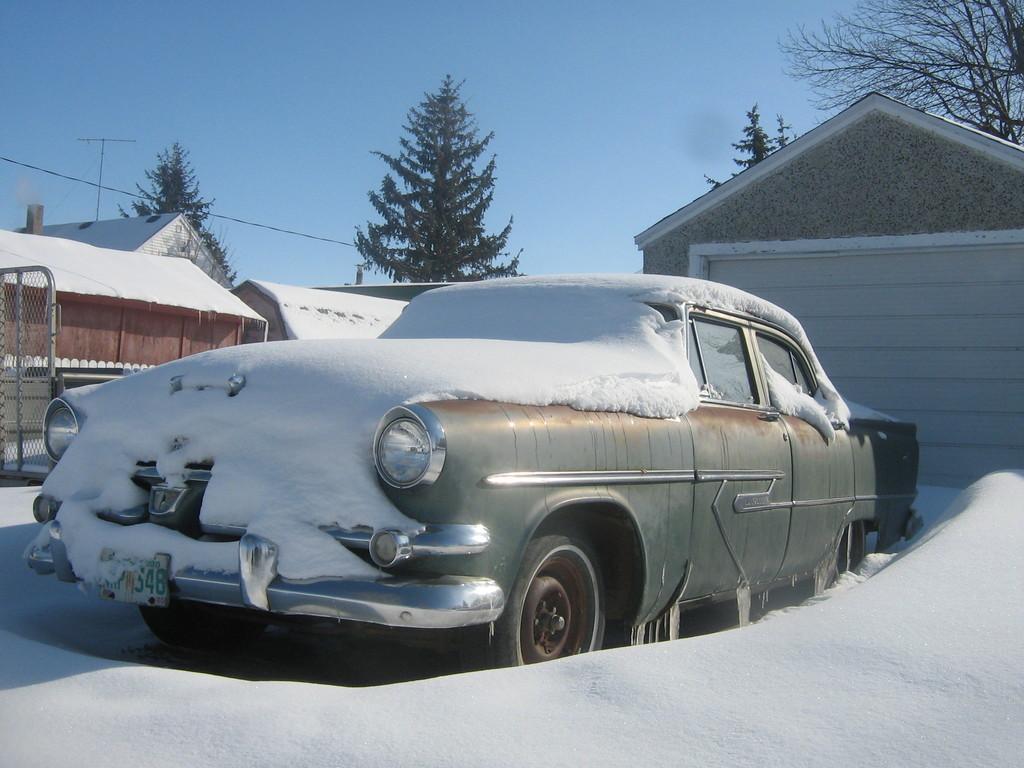Describe this image in one or two sentences. In the image we can see the vehicle covered with snow and these are the headlights and number plate of the vehicle. We can even see there are many houses and trees. Here we can see electric poles, electric wires, mesh and the sky. 